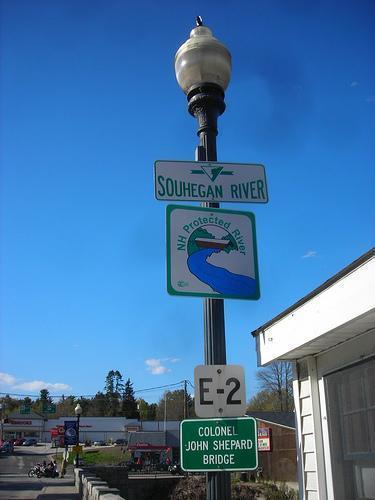How many r's are in the highest sign?
Give a very brief answer. 2. 